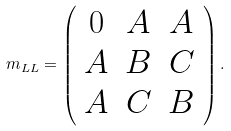Convert formula to latex. <formula><loc_0><loc_0><loc_500><loc_500>m _ { L L } = \left ( \begin{array} { c c c } 0 & A & A \\ A & B & C \\ A & C & B \end{array} \right ) .</formula> 